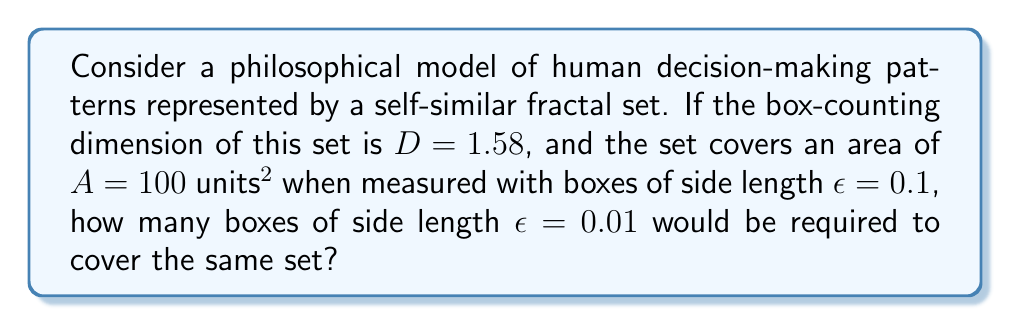What is the answer to this math problem? To solve this problem, we'll use the box-counting dimension formula and the properties of fractal scaling:

1) The box-counting dimension $D$ is defined as:

   $$D = \lim_{\epsilon \to 0} \frac{\log N(\epsilon)}{\log(1/\epsilon)}$$

   where $N(\epsilon)$ is the number of boxes of side length $\epsilon$ needed to cover the set.

2) For a self-similar fractal, this relationship holds for finite $\epsilon$:

   $$N(\epsilon) = k \cdot \epsilon^{-D}$$

   where $k$ is a constant.

3) We're given two points: 
   - When $\epsilon_1 = 0.1$, $N(\epsilon_1) = 100 / (0.1)^2 = 10000$
   - We need to find $N(\epsilon_2)$ when $\epsilon_2 = 0.01$

4) Using the first point, we can find $k$:

   $$10000 = k \cdot (0.1)^{-1.58}$$
   $$k = 10000 \cdot (0.1)^{1.58} \approx 661.91$$

5) Now we can use this $k$ to find $N(\epsilon_2)$:

   $$N(0.01) = 661.91 \cdot (0.01)^{-1.58}$$
   $$N(0.01) \approx 661.91 \cdot 2511.89 \approx 1,662,683.95$$

6) Rounding to the nearest whole number of boxes:

   $$N(0.01) \approx 1,662,684$$

This result suggests that as we examine human decision-making patterns at finer scales, the complexity increases dramatically, revealing intricate structures that challenge simplistic notions of personal identity and free will.
Answer: 1,662,684 boxes 